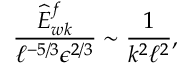Convert formula to latex. <formula><loc_0><loc_0><loc_500><loc_500>\frac { \widehat { E } _ { w k } ^ { f } } { \ell ^ { - 5 / 3 } \epsilon ^ { 2 / 3 } } \sim \frac { 1 } { k ^ { 2 } \ell ^ { 2 } } ,</formula> 